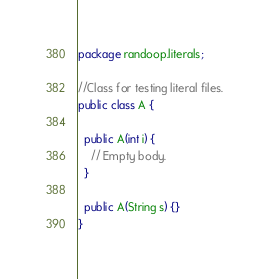<code> <loc_0><loc_0><loc_500><loc_500><_Java_>package randoop.literals;

//Class for testing literal files.
public class A {

  public A(int i) {
    // Empty body.
  }

  public A(String s) {}
}
</code> 